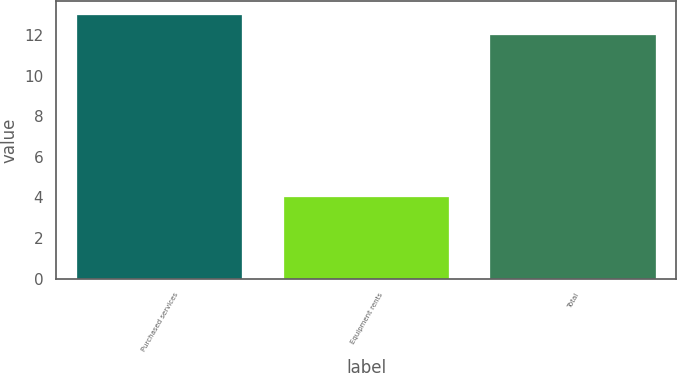Convert chart to OTSL. <chart><loc_0><loc_0><loc_500><loc_500><bar_chart><fcel>Purchased services<fcel>Equipment rents<fcel>Total<nl><fcel>13<fcel>4<fcel>12<nl></chart> 